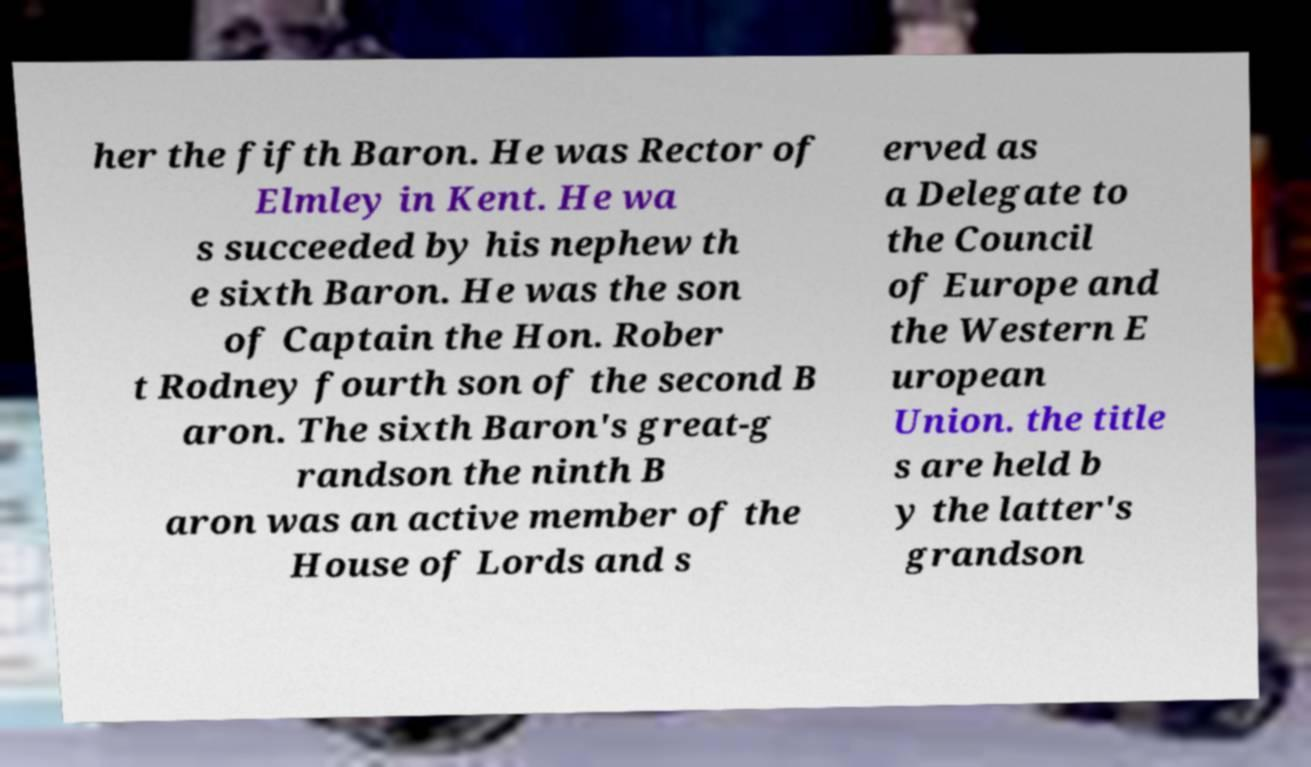I need the written content from this picture converted into text. Can you do that? her the fifth Baron. He was Rector of Elmley in Kent. He wa s succeeded by his nephew th e sixth Baron. He was the son of Captain the Hon. Rober t Rodney fourth son of the second B aron. The sixth Baron's great-g randson the ninth B aron was an active member of the House of Lords and s erved as a Delegate to the Council of Europe and the Western E uropean Union. the title s are held b y the latter's grandson 